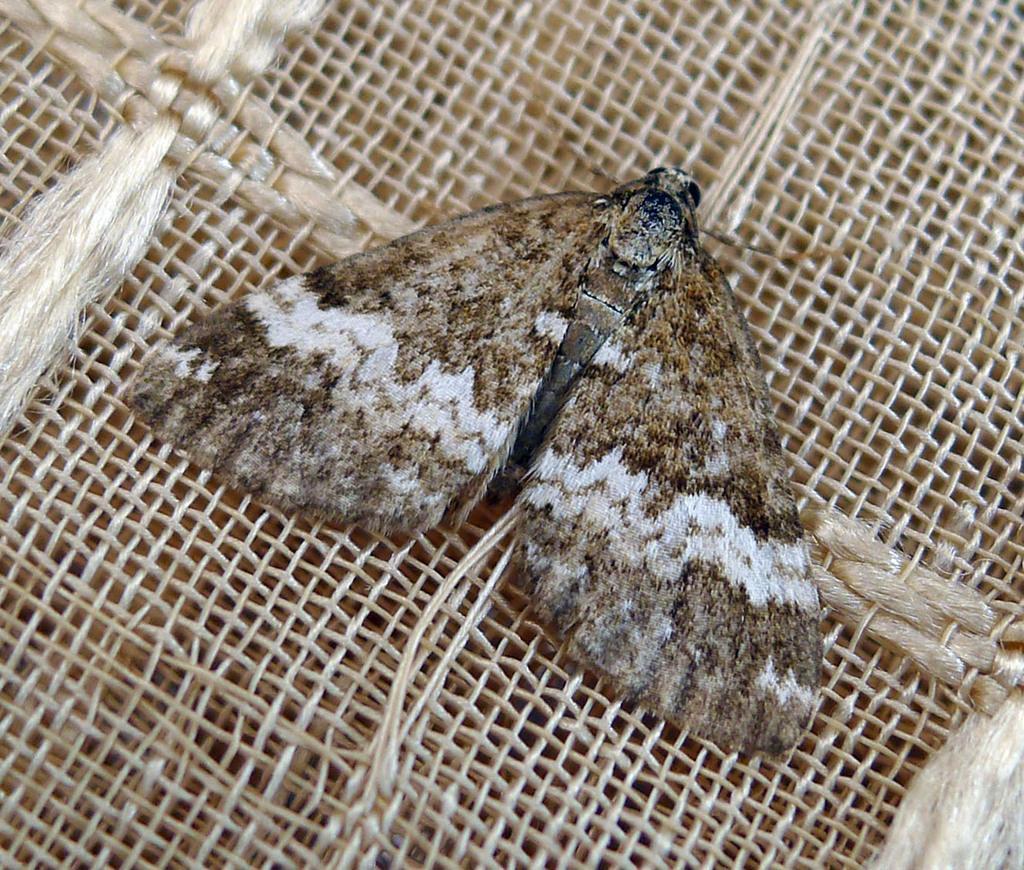How would you summarize this image in a sentence or two? In this image we can see an insect on the jute mat. 